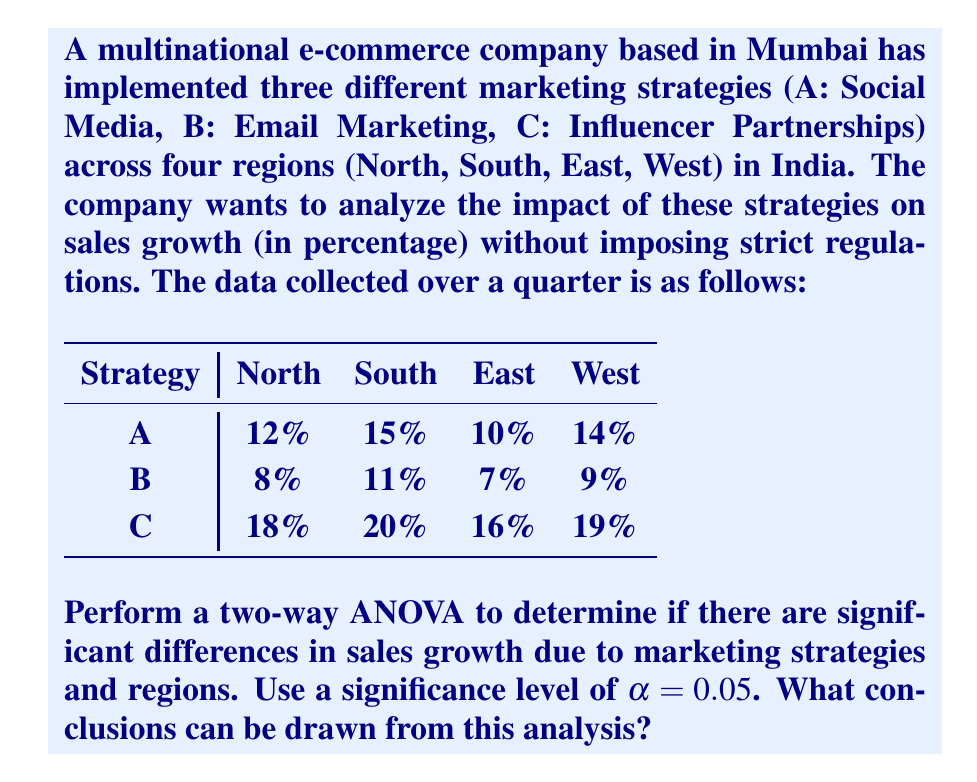Can you answer this question? To perform a two-way ANOVA, we need to follow these steps:

1. Calculate the total sum of squares (SST)
2. Calculate the sum of squares for marketing strategies (SSA)
3. Calculate the sum of squares for regions (SSB)
4. Calculate the sum of squares for interaction (SSAB)
5. Calculate the sum of squares for error (SSE)
6. Calculate the degrees of freedom
7. Calculate the mean squares
8. Calculate the F-ratios
9. Compare F-ratios with critical F-values

Step 1: Calculate SST

First, we need to calculate the grand mean:
$$\bar{X} = \frac{159}{12} = 13.25$$

Now, we can calculate SST:
$$SST = \sum_{i=1}^{3}\sum_{j=1}^{4}(X_{ij} - \bar{X})^2 = 228.75$$

Step 2: Calculate SSA

Calculate the means for each marketing strategy:
$$\bar{A} = 12.75, \bar{B} = 8.75, \bar{C} = 18.25$$

Now, calculate SSA:
$$SSA = 4\sum_{i=1}^{3}(\bar{A_i} - \bar{X})^2 = 180.5$$

Step 3: Calculate SSB

Calculate the means for each region:
$$\bar{North} = 12.67, \bar{South} = 15.33, \bar{East} = 11, \bar{West} = 14$$

Now, calculate SSB:
$$SSB = 3\sum_{j=1}^{4}(\bar{B_j} - \bar{X})^2 = 28.25$$

Step 4: Calculate SSAB

$$SSAB = \sum_{i=1}^{3}\sum_{j=1}^{4}(\bar{X_{ij}} - \bar{A_i} - \bar{B_j} + \bar{X})^2 = 1.5$$

Step 5: Calculate SSE

$$SSE = SST - SSA - SSB - SSAB = 18.5$$

Step 6: Calculate degrees of freedom

$$df_A = 2, df_B = 3, df_{AB} = 6, df_E = 6, df_T = 11$$

Step 7: Calculate mean squares

$$MSA = \frac{SSA}{df_A} = 90.25$$
$$MSB = \frac{SSB}{df_B} = 9.42$$
$$MSAB = \frac{SSAB}{df_{AB}} = 0.25$$
$$MSE = \frac{SSE}{df_E} = 3.08$$

Step 8: Calculate F-ratios

$$F_A = \frac{MSA}{MSE} = 29.30$$
$$F_B = \frac{MSB}{MSE} = 3.06$$
$$F_{AB} = \frac{MSAB}{MSE} = 0.08$$

Step 9: Compare F-ratios with critical F-values

For $\alpha = 0.05$:
$$F_{crit(A)} = F_{0.05,2,6} = 5.14$$
$$F_{crit(B)} = F_{0.05,3,6} = 4.76$$
$$F_{crit(AB)} = F_{0.05,6,6} = 4.28$$

Comparing the F-ratios with their respective critical F-values:

1. $F_A > F_{crit(A)}$: There is a significant difference in sales growth due to marketing strategies.
2. $F_B < F_{crit(B)}$: There is no significant difference in sales growth due to regions.
3. $F_{AB} < F_{crit(AB)}$: There is no significant interaction effect between marketing strategies and regions.
Answer: Based on the two-way ANOVA analysis:

1. Marketing strategies have a significant impact on sales growth (F = 29.30 > 5.14).
2. Regions do not have a significant impact on sales growth (F = 3.06 < 4.76).
3. There is no significant interaction effect between marketing strategies and regions (F = 0.08 < 4.28).

The e-commerce company can conclude that different marketing strategies significantly affect sales growth, while regional differences and the interaction between strategies and regions do not have a significant impact. This suggests that the company can focus on optimizing its marketing strategies without the need for region-specific regulations or adaptations. 